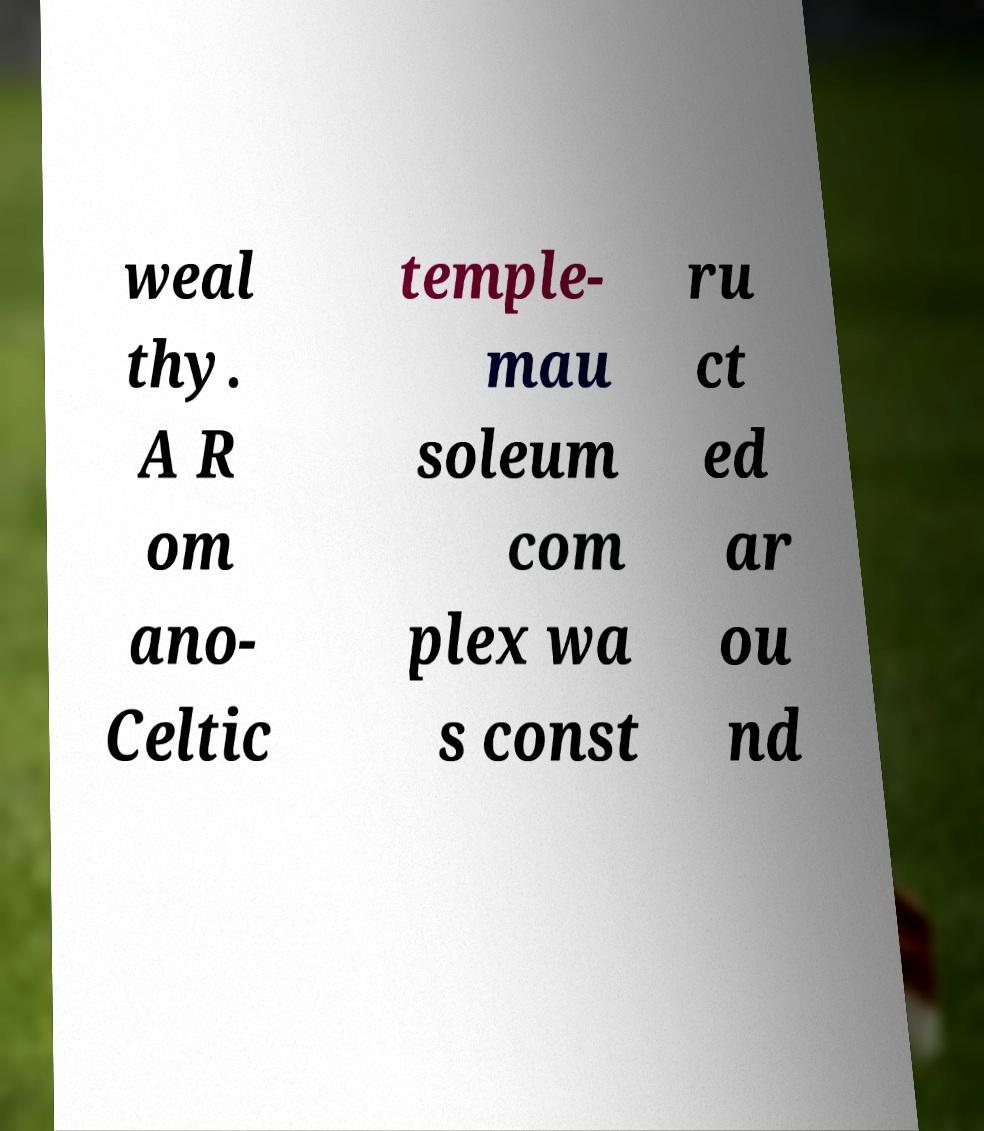Please read and relay the text visible in this image. What does it say? weal thy. A R om ano- Celtic temple- mau soleum com plex wa s const ru ct ed ar ou nd 